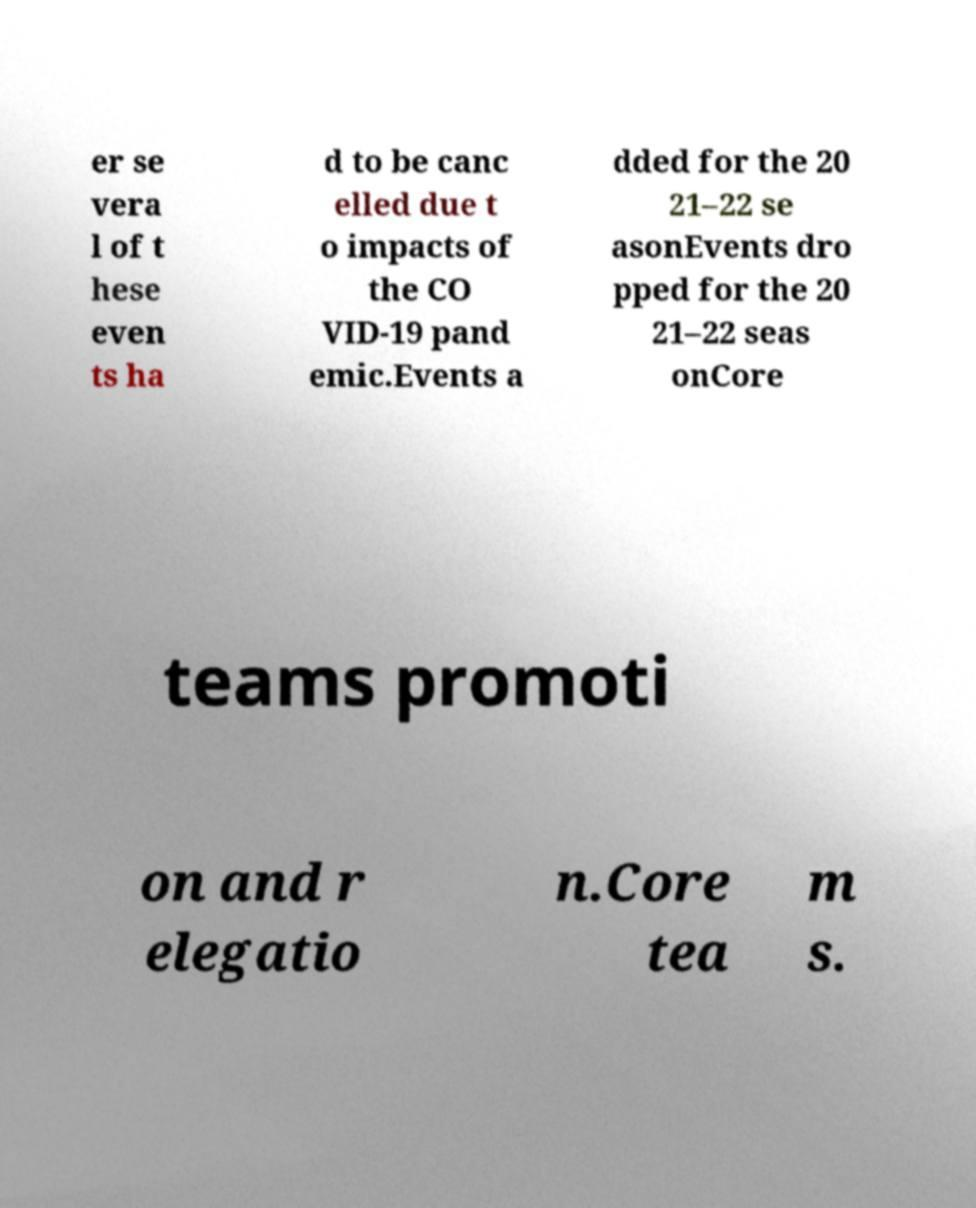Could you extract and type out the text from this image? er se vera l of t hese even ts ha d to be canc elled due t o impacts of the CO VID-19 pand emic.Events a dded for the 20 21–22 se asonEvents dro pped for the 20 21–22 seas onCore teams promoti on and r elegatio n.Core tea m s. 